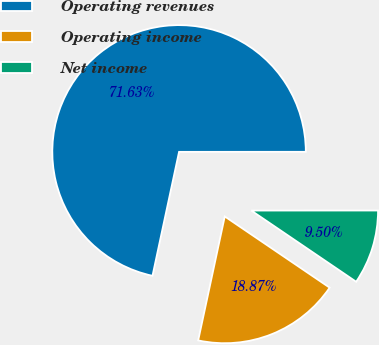Convert chart to OTSL. <chart><loc_0><loc_0><loc_500><loc_500><pie_chart><fcel>Operating revenues<fcel>Operating income<fcel>Net income<nl><fcel>71.64%<fcel>18.87%<fcel>9.5%<nl></chart> 